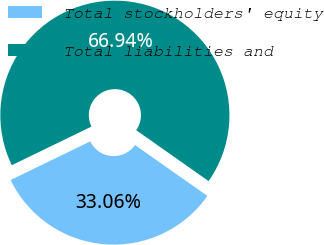<chart> <loc_0><loc_0><loc_500><loc_500><pie_chart><fcel>Total stockholders' equity<fcel>Total liabilities and<nl><fcel>33.06%<fcel>66.94%<nl></chart> 